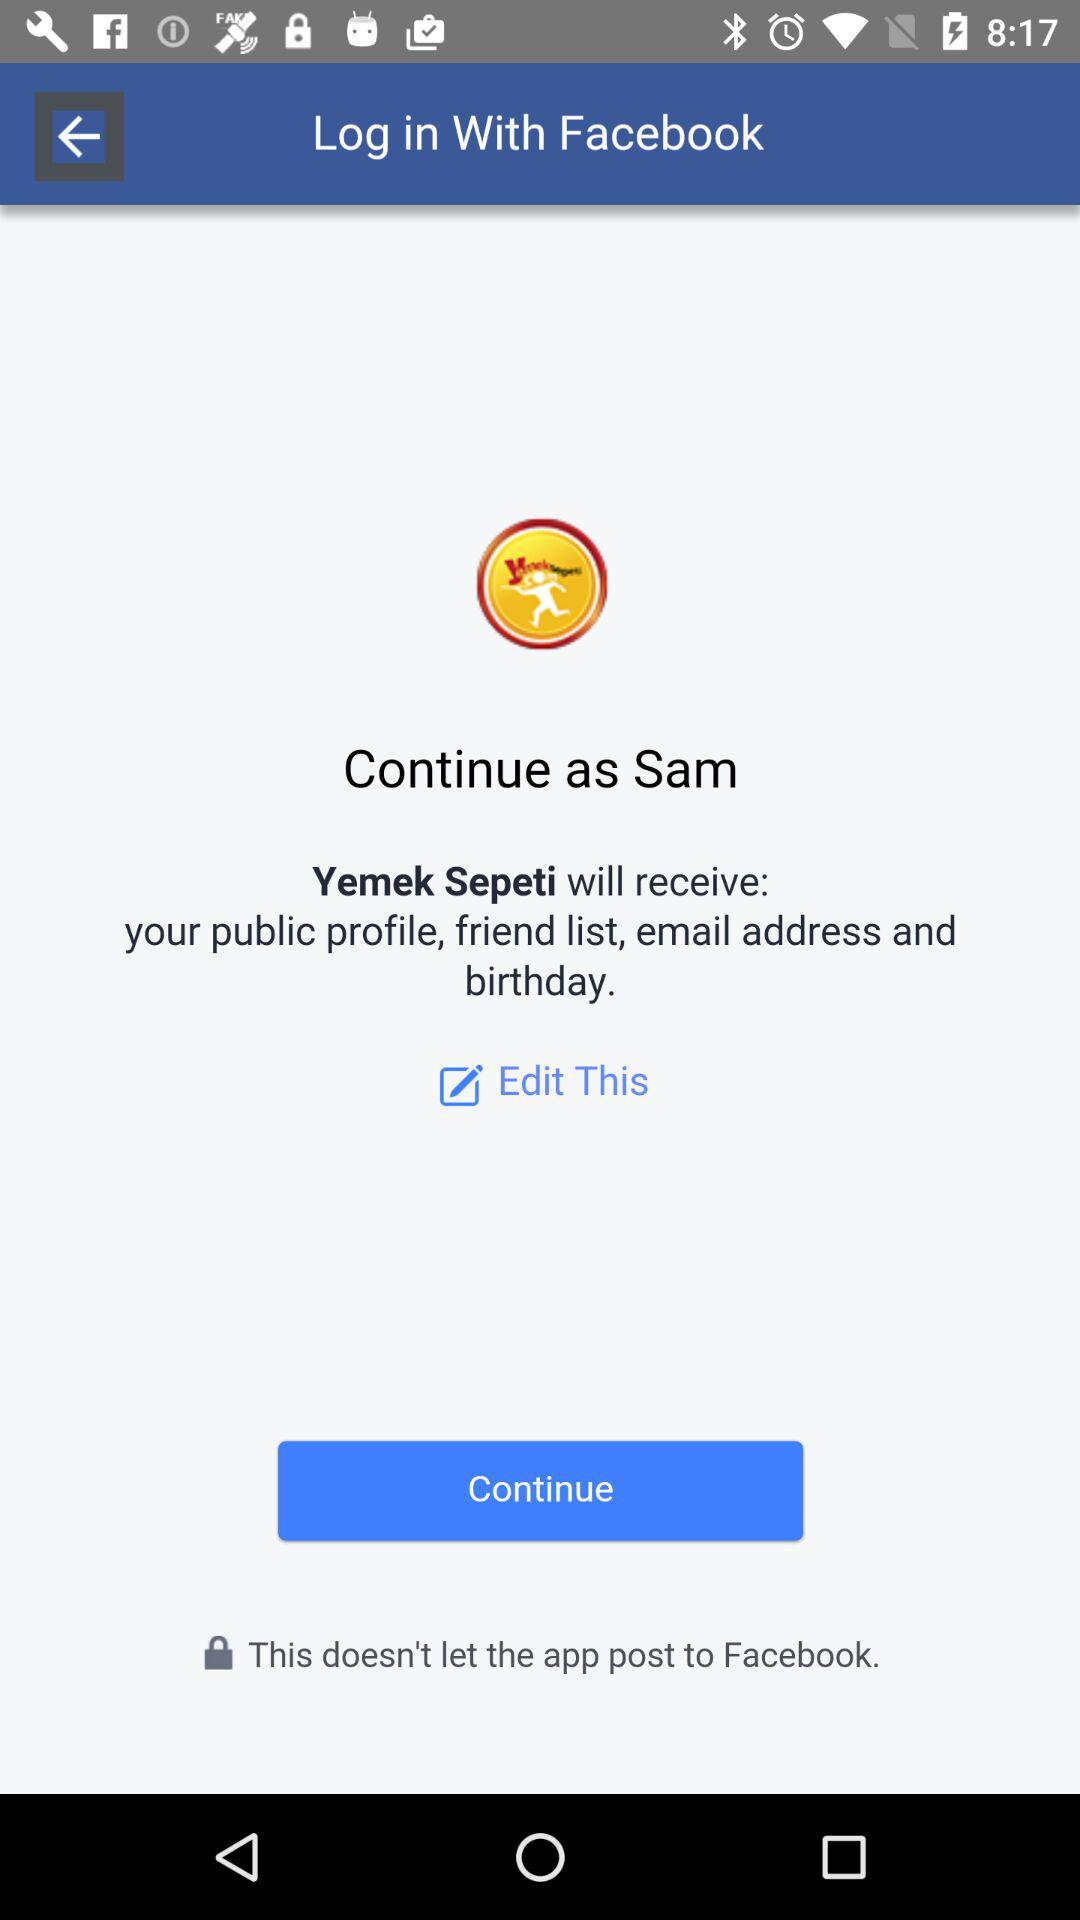What application is asking for permission? The application asking for permission is "Yemek Sepeti". 